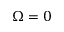Convert formula to latex. <formula><loc_0><loc_0><loc_500><loc_500>\Omega = 0</formula> 